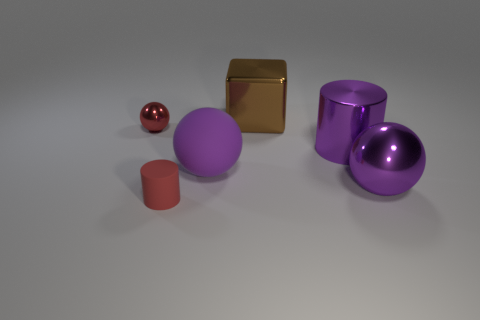There is a metallic cylinder that is the same size as the matte ball; what color is it? The metallic cylinder that is approximately the same size as the matte ball is purple. This hue of purple exhibits a reflective sheen indicative of its being metallic, differentiating it from the matte texture of the ball. 